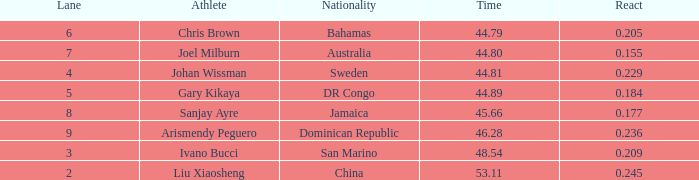How many total Time listings have a 0.209 React entry and a Rank that is greater than 7? 0.0. 